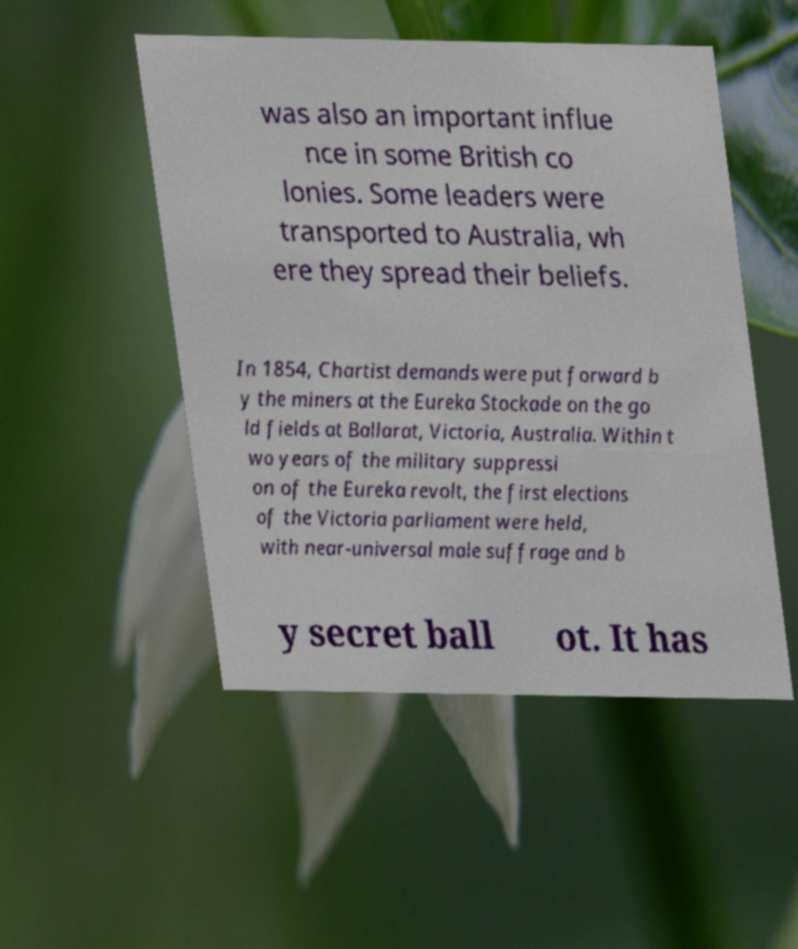Please identify and transcribe the text found in this image. was also an important influe nce in some British co lonies. Some leaders were transported to Australia, wh ere they spread their beliefs. In 1854, Chartist demands were put forward b y the miners at the Eureka Stockade on the go ld fields at Ballarat, Victoria, Australia. Within t wo years of the military suppressi on of the Eureka revolt, the first elections of the Victoria parliament were held, with near-universal male suffrage and b y secret ball ot. It has 